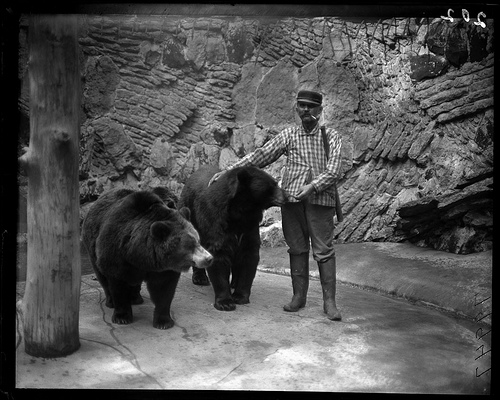Which bear has an open mouth? It appears that the bears in the image have their mouths closed. However, the bear on the right has a slightly agape mouth, though not fully open, suggesting a subtle expression that might interest observers. 